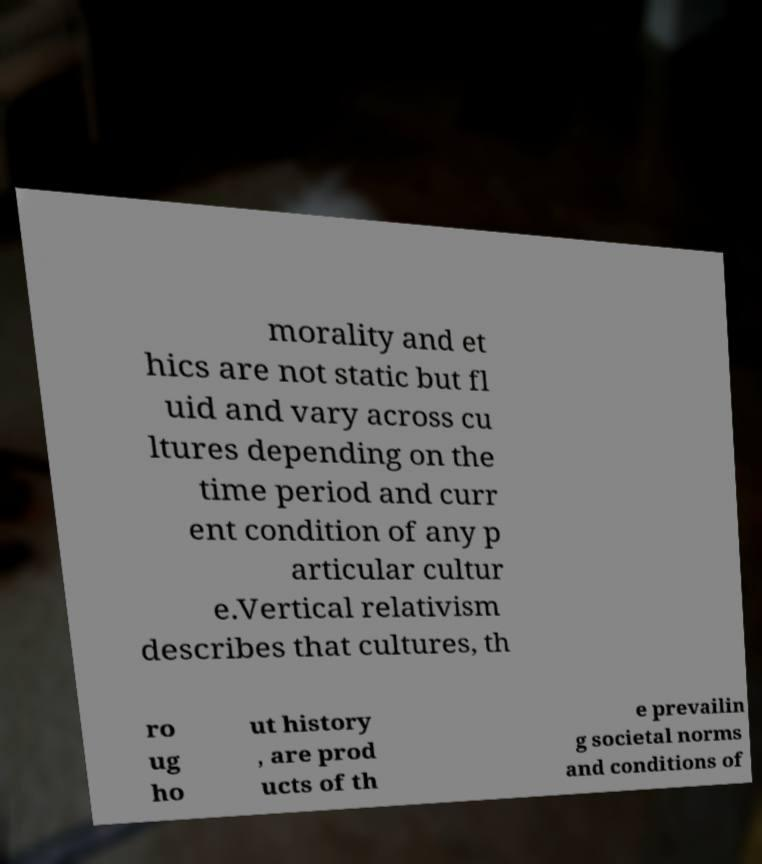For documentation purposes, I need the text within this image transcribed. Could you provide that? morality and et hics are not static but fl uid and vary across cu ltures depending on the time period and curr ent condition of any p articular cultur e.Vertical relativism describes that cultures, th ro ug ho ut history , are prod ucts of th e prevailin g societal norms and conditions of 